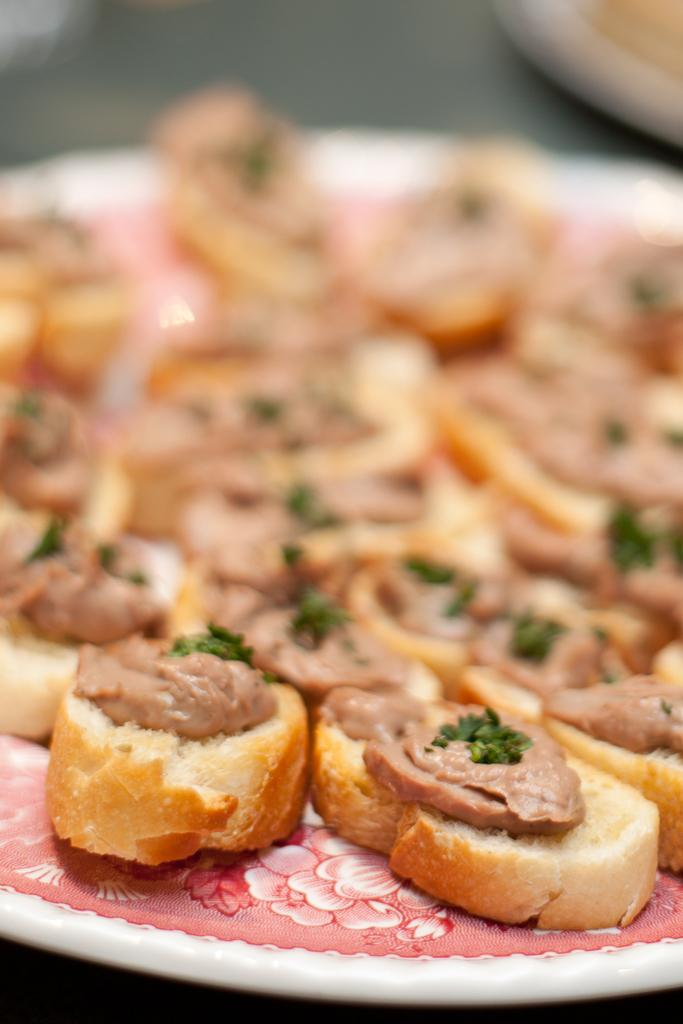What type of food can be seen in the image? There is bread and meat pieces in the image. How are the bread and meat pieces arranged in the image? The bread and meat pieces are on a plate. Where is the plate located in the image? The plate is on a table. Can you describe the image visible at the top of the image? The image visible at the top of the image is blurry. What type of rose can be seen in the image? There is no rose present in the image; it features bread and meat pieces on a plate. How does the pollution affect the bread and meat pieces in the image? There is no indication of pollution in the image, as it only shows bread and meat pieces on a plate. 